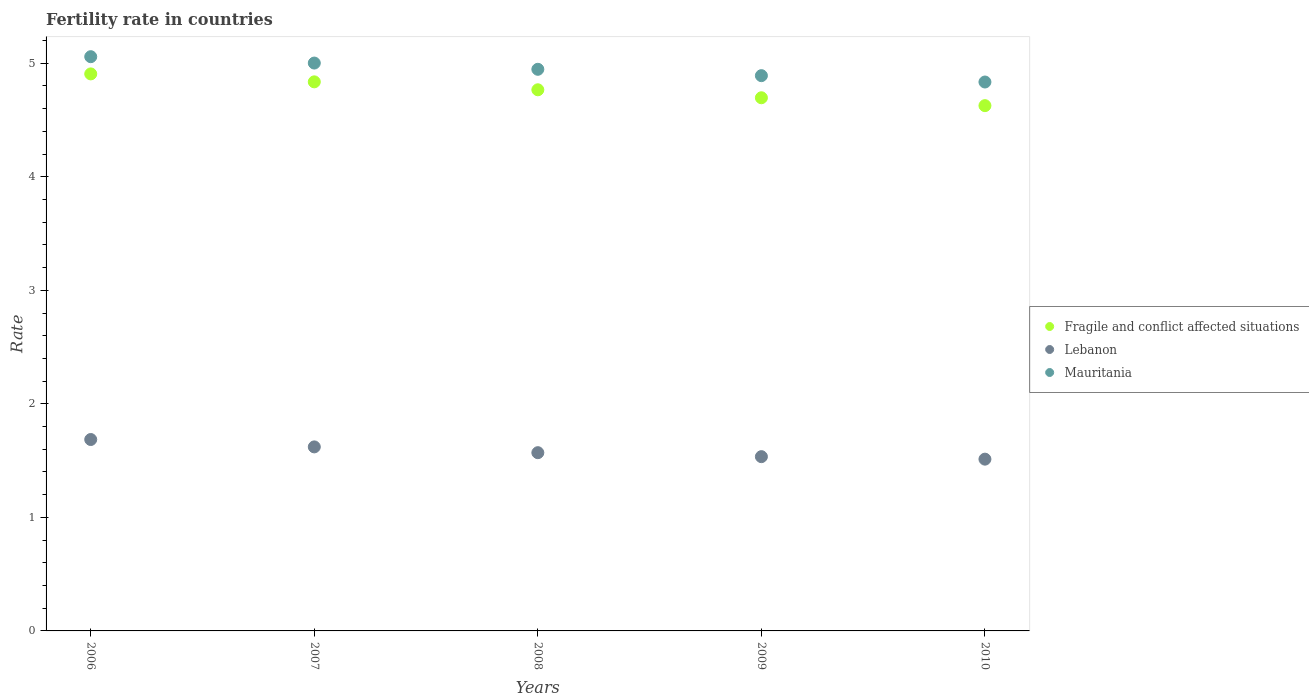How many different coloured dotlines are there?
Keep it short and to the point. 3. Is the number of dotlines equal to the number of legend labels?
Your response must be concise. Yes. What is the fertility rate in Lebanon in 2008?
Offer a terse response. 1.57. Across all years, what is the maximum fertility rate in Mauritania?
Provide a succinct answer. 5.06. Across all years, what is the minimum fertility rate in Fragile and conflict affected situations?
Your answer should be compact. 4.63. In which year was the fertility rate in Fragile and conflict affected situations maximum?
Ensure brevity in your answer.  2006. What is the total fertility rate in Fragile and conflict affected situations in the graph?
Provide a short and direct response. 23.83. What is the difference between the fertility rate in Fragile and conflict affected situations in 2007 and that in 2008?
Your answer should be compact. 0.07. What is the difference between the fertility rate in Fragile and conflict affected situations in 2009 and the fertility rate in Mauritania in 2010?
Offer a terse response. -0.14. What is the average fertility rate in Fragile and conflict affected situations per year?
Offer a terse response. 4.77. In the year 2010, what is the difference between the fertility rate in Fragile and conflict affected situations and fertility rate in Lebanon?
Keep it short and to the point. 3.11. What is the ratio of the fertility rate in Fragile and conflict affected situations in 2006 to that in 2010?
Provide a succinct answer. 1.06. What is the difference between the highest and the second highest fertility rate in Fragile and conflict affected situations?
Your answer should be very brief. 0.07. What is the difference between the highest and the lowest fertility rate in Lebanon?
Provide a succinct answer. 0.17. Is it the case that in every year, the sum of the fertility rate in Lebanon and fertility rate in Fragile and conflict affected situations  is greater than the fertility rate in Mauritania?
Your response must be concise. Yes. How many dotlines are there?
Offer a terse response. 3. How many years are there in the graph?
Offer a terse response. 5. What is the difference between two consecutive major ticks on the Y-axis?
Give a very brief answer. 1. Are the values on the major ticks of Y-axis written in scientific E-notation?
Provide a succinct answer. No. How many legend labels are there?
Ensure brevity in your answer.  3. What is the title of the graph?
Offer a terse response. Fertility rate in countries. Does "Sao Tome and Principe" appear as one of the legend labels in the graph?
Ensure brevity in your answer.  No. What is the label or title of the X-axis?
Offer a very short reply. Years. What is the label or title of the Y-axis?
Your answer should be very brief. Rate. What is the Rate of Fragile and conflict affected situations in 2006?
Keep it short and to the point. 4.91. What is the Rate in Lebanon in 2006?
Ensure brevity in your answer.  1.69. What is the Rate of Mauritania in 2006?
Your response must be concise. 5.06. What is the Rate of Fragile and conflict affected situations in 2007?
Make the answer very short. 4.84. What is the Rate in Lebanon in 2007?
Offer a terse response. 1.62. What is the Rate of Mauritania in 2007?
Offer a very short reply. 5. What is the Rate in Fragile and conflict affected situations in 2008?
Ensure brevity in your answer.  4.77. What is the Rate of Lebanon in 2008?
Provide a succinct answer. 1.57. What is the Rate in Mauritania in 2008?
Give a very brief answer. 4.95. What is the Rate of Fragile and conflict affected situations in 2009?
Keep it short and to the point. 4.7. What is the Rate in Lebanon in 2009?
Provide a short and direct response. 1.53. What is the Rate in Mauritania in 2009?
Give a very brief answer. 4.89. What is the Rate of Fragile and conflict affected situations in 2010?
Your answer should be compact. 4.63. What is the Rate of Lebanon in 2010?
Offer a terse response. 1.51. What is the Rate in Mauritania in 2010?
Provide a succinct answer. 4.83. Across all years, what is the maximum Rate of Fragile and conflict affected situations?
Ensure brevity in your answer.  4.91. Across all years, what is the maximum Rate of Lebanon?
Your response must be concise. 1.69. Across all years, what is the maximum Rate of Mauritania?
Provide a short and direct response. 5.06. Across all years, what is the minimum Rate of Fragile and conflict affected situations?
Offer a terse response. 4.63. Across all years, what is the minimum Rate in Lebanon?
Give a very brief answer. 1.51. Across all years, what is the minimum Rate in Mauritania?
Keep it short and to the point. 4.83. What is the total Rate of Fragile and conflict affected situations in the graph?
Your response must be concise. 23.83. What is the total Rate in Lebanon in the graph?
Make the answer very short. 7.92. What is the total Rate of Mauritania in the graph?
Your response must be concise. 24.73. What is the difference between the Rate of Fragile and conflict affected situations in 2006 and that in 2007?
Your answer should be compact. 0.07. What is the difference between the Rate of Lebanon in 2006 and that in 2007?
Offer a terse response. 0.07. What is the difference between the Rate of Mauritania in 2006 and that in 2007?
Give a very brief answer. 0.06. What is the difference between the Rate in Fragile and conflict affected situations in 2006 and that in 2008?
Make the answer very short. 0.14. What is the difference between the Rate in Lebanon in 2006 and that in 2008?
Keep it short and to the point. 0.12. What is the difference between the Rate in Mauritania in 2006 and that in 2008?
Your response must be concise. 0.11. What is the difference between the Rate in Fragile and conflict affected situations in 2006 and that in 2009?
Offer a terse response. 0.21. What is the difference between the Rate in Lebanon in 2006 and that in 2009?
Your response must be concise. 0.15. What is the difference between the Rate in Mauritania in 2006 and that in 2009?
Provide a short and direct response. 0.17. What is the difference between the Rate of Fragile and conflict affected situations in 2006 and that in 2010?
Your response must be concise. 0.28. What is the difference between the Rate in Lebanon in 2006 and that in 2010?
Provide a succinct answer. 0.17. What is the difference between the Rate of Mauritania in 2006 and that in 2010?
Offer a very short reply. 0.22. What is the difference between the Rate of Fragile and conflict affected situations in 2007 and that in 2008?
Ensure brevity in your answer.  0.07. What is the difference between the Rate in Lebanon in 2007 and that in 2008?
Keep it short and to the point. 0.05. What is the difference between the Rate in Mauritania in 2007 and that in 2008?
Offer a very short reply. 0.06. What is the difference between the Rate in Fragile and conflict affected situations in 2007 and that in 2009?
Your answer should be very brief. 0.14. What is the difference between the Rate in Lebanon in 2007 and that in 2009?
Your answer should be compact. 0.09. What is the difference between the Rate in Mauritania in 2007 and that in 2009?
Provide a succinct answer. 0.11. What is the difference between the Rate in Fragile and conflict affected situations in 2007 and that in 2010?
Provide a succinct answer. 0.21. What is the difference between the Rate of Lebanon in 2007 and that in 2010?
Make the answer very short. 0.11. What is the difference between the Rate in Mauritania in 2007 and that in 2010?
Your answer should be very brief. 0.17. What is the difference between the Rate in Fragile and conflict affected situations in 2008 and that in 2009?
Give a very brief answer. 0.07. What is the difference between the Rate in Lebanon in 2008 and that in 2009?
Offer a terse response. 0.04. What is the difference between the Rate in Mauritania in 2008 and that in 2009?
Your answer should be compact. 0.06. What is the difference between the Rate of Fragile and conflict affected situations in 2008 and that in 2010?
Provide a short and direct response. 0.14. What is the difference between the Rate in Lebanon in 2008 and that in 2010?
Offer a very short reply. 0.06. What is the difference between the Rate in Mauritania in 2008 and that in 2010?
Provide a succinct answer. 0.11. What is the difference between the Rate of Fragile and conflict affected situations in 2009 and that in 2010?
Ensure brevity in your answer.  0.07. What is the difference between the Rate in Lebanon in 2009 and that in 2010?
Your response must be concise. 0.02. What is the difference between the Rate in Mauritania in 2009 and that in 2010?
Keep it short and to the point. 0.06. What is the difference between the Rate in Fragile and conflict affected situations in 2006 and the Rate in Lebanon in 2007?
Give a very brief answer. 3.29. What is the difference between the Rate in Fragile and conflict affected situations in 2006 and the Rate in Mauritania in 2007?
Give a very brief answer. -0.1. What is the difference between the Rate in Lebanon in 2006 and the Rate in Mauritania in 2007?
Make the answer very short. -3.32. What is the difference between the Rate of Fragile and conflict affected situations in 2006 and the Rate of Lebanon in 2008?
Make the answer very short. 3.34. What is the difference between the Rate in Fragile and conflict affected situations in 2006 and the Rate in Mauritania in 2008?
Give a very brief answer. -0.04. What is the difference between the Rate in Lebanon in 2006 and the Rate in Mauritania in 2008?
Offer a very short reply. -3.26. What is the difference between the Rate of Fragile and conflict affected situations in 2006 and the Rate of Lebanon in 2009?
Offer a terse response. 3.37. What is the difference between the Rate of Fragile and conflict affected situations in 2006 and the Rate of Mauritania in 2009?
Your answer should be very brief. 0.02. What is the difference between the Rate of Lebanon in 2006 and the Rate of Mauritania in 2009?
Make the answer very short. -3.21. What is the difference between the Rate of Fragile and conflict affected situations in 2006 and the Rate of Lebanon in 2010?
Provide a short and direct response. 3.39. What is the difference between the Rate of Fragile and conflict affected situations in 2006 and the Rate of Mauritania in 2010?
Offer a terse response. 0.07. What is the difference between the Rate in Lebanon in 2006 and the Rate in Mauritania in 2010?
Your answer should be very brief. -3.15. What is the difference between the Rate in Fragile and conflict affected situations in 2007 and the Rate in Lebanon in 2008?
Your answer should be very brief. 3.27. What is the difference between the Rate of Fragile and conflict affected situations in 2007 and the Rate of Mauritania in 2008?
Keep it short and to the point. -0.11. What is the difference between the Rate in Lebanon in 2007 and the Rate in Mauritania in 2008?
Offer a terse response. -3.33. What is the difference between the Rate of Fragile and conflict affected situations in 2007 and the Rate of Lebanon in 2009?
Your answer should be very brief. 3.3. What is the difference between the Rate in Fragile and conflict affected situations in 2007 and the Rate in Mauritania in 2009?
Provide a short and direct response. -0.05. What is the difference between the Rate in Lebanon in 2007 and the Rate in Mauritania in 2009?
Offer a terse response. -3.27. What is the difference between the Rate in Fragile and conflict affected situations in 2007 and the Rate in Lebanon in 2010?
Your response must be concise. 3.32. What is the difference between the Rate of Fragile and conflict affected situations in 2007 and the Rate of Mauritania in 2010?
Your answer should be compact. 0. What is the difference between the Rate in Lebanon in 2007 and the Rate in Mauritania in 2010?
Make the answer very short. -3.21. What is the difference between the Rate in Fragile and conflict affected situations in 2008 and the Rate in Lebanon in 2009?
Give a very brief answer. 3.23. What is the difference between the Rate in Fragile and conflict affected situations in 2008 and the Rate in Mauritania in 2009?
Offer a terse response. -0.12. What is the difference between the Rate of Lebanon in 2008 and the Rate of Mauritania in 2009?
Your response must be concise. -3.32. What is the difference between the Rate in Fragile and conflict affected situations in 2008 and the Rate in Lebanon in 2010?
Keep it short and to the point. 3.25. What is the difference between the Rate of Fragile and conflict affected situations in 2008 and the Rate of Mauritania in 2010?
Offer a terse response. -0.07. What is the difference between the Rate of Lebanon in 2008 and the Rate of Mauritania in 2010?
Make the answer very short. -3.27. What is the difference between the Rate of Fragile and conflict affected situations in 2009 and the Rate of Lebanon in 2010?
Provide a succinct answer. 3.18. What is the difference between the Rate in Fragile and conflict affected situations in 2009 and the Rate in Mauritania in 2010?
Your response must be concise. -0.14. What is the difference between the Rate of Lebanon in 2009 and the Rate of Mauritania in 2010?
Make the answer very short. -3.3. What is the average Rate of Fragile and conflict affected situations per year?
Give a very brief answer. 4.77. What is the average Rate in Lebanon per year?
Offer a very short reply. 1.58. What is the average Rate in Mauritania per year?
Provide a short and direct response. 4.95. In the year 2006, what is the difference between the Rate of Fragile and conflict affected situations and Rate of Lebanon?
Keep it short and to the point. 3.22. In the year 2006, what is the difference between the Rate of Fragile and conflict affected situations and Rate of Mauritania?
Provide a short and direct response. -0.15. In the year 2006, what is the difference between the Rate in Lebanon and Rate in Mauritania?
Make the answer very short. -3.37. In the year 2007, what is the difference between the Rate of Fragile and conflict affected situations and Rate of Lebanon?
Your answer should be compact. 3.22. In the year 2007, what is the difference between the Rate in Fragile and conflict affected situations and Rate in Mauritania?
Your answer should be compact. -0.17. In the year 2007, what is the difference between the Rate of Lebanon and Rate of Mauritania?
Offer a very short reply. -3.38. In the year 2008, what is the difference between the Rate in Fragile and conflict affected situations and Rate in Lebanon?
Provide a succinct answer. 3.2. In the year 2008, what is the difference between the Rate in Fragile and conflict affected situations and Rate in Mauritania?
Provide a short and direct response. -0.18. In the year 2008, what is the difference between the Rate of Lebanon and Rate of Mauritania?
Give a very brief answer. -3.38. In the year 2009, what is the difference between the Rate of Fragile and conflict affected situations and Rate of Lebanon?
Make the answer very short. 3.16. In the year 2009, what is the difference between the Rate in Fragile and conflict affected situations and Rate in Mauritania?
Keep it short and to the point. -0.19. In the year 2009, what is the difference between the Rate of Lebanon and Rate of Mauritania?
Ensure brevity in your answer.  -3.36. In the year 2010, what is the difference between the Rate in Fragile and conflict affected situations and Rate in Lebanon?
Offer a terse response. 3.11. In the year 2010, what is the difference between the Rate of Fragile and conflict affected situations and Rate of Mauritania?
Your answer should be very brief. -0.21. In the year 2010, what is the difference between the Rate of Lebanon and Rate of Mauritania?
Your response must be concise. -3.32. What is the ratio of the Rate of Fragile and conflict affected situations in 2006 to that in 2007?
Offer a terse response. 1.01. What is the ratio of the Rate of Lebanon in 2006 to that in 2007?
Offer a terse response. 1.04. What is the ratio of the Rate in Mauritania in 2006 to that in 2007?
Offer a very short reply. 1.01. What is the ratio of the Rate of Fragile and conflict affected situations in 2006 to that in 2008?
Ensure brevity in your answer.  1.03. What is the ratio of the Rate of Lebanon in 2006 to that in 2008?
Ensure brevity in your answer.  1.07. What is the ratio of the Rate of Mauritania in 2006 to that in 2008?
Your answer should be very brief. 1.02. What is the ratio of the Rate of Fragile and conflict affected situations in 2006 to that in 2009?
Offer a very short reply. 1.04. What is the ratio of the Rate in Lebanon in 2006 to that in 2009?
Offer a terse response. 1.1. What is the ratio of the Rate of Mauritania in 2006 to that in 2009?
Your response must be concise. 1.03. What is the ratio of the Rate of Fragile and conflict affected situations in 2006 to that in 2010?
Keep it short and to the point. 1.06. What is the ratio of the Rate in Lebanon in 2006 to that in 2010?
Offer a terse response. 1.11. What is the ratio of the Rate in Mauritania in 2006 to that in 2010?
Keep it short and to the point. 1.05. What is the ratio of the Rate of Fragile and conflict affected situations in 2007 to that in 2008?
Ensure brevity in your answer.  1.01. What is the ratio of the Rate in Lebanon in 2007 to that in 2008?
Provide a succinct answer. 1.03. What is the ratio of the Rate of Mauritania in 2007 to that in 2008?
Provide a short and direct response. 1.01. What is the ratio of the Rate of Fragile and conflict affected situations in 2007 to that in 2009?
Offer a terse response. 1.03. What is the ratio of the Rate in Lebanon in 2007 to that in 2009?
Provide a succinct answer. 1.06. What is the ratio of the Rate in Mauritania in 2007 to that in 2009?
Keep it short and to the point. 1.02. What is the ratio of the Rate in Fragile and conflict affected situations in 2007 to that in 2010?
Your response must be concise. 1.05. What is the ratio of the Rate in Lebanon in 2007 to that in 2010?
Keep it short and to the point. 1.07. What is the ratio of the Rate in Mauritania in 2007 to that in 2010?
Provide a succinct answer. 1.03. What is the ratio of the Rate in Lebanon in 2008 to that in 2009?
Offer a terse response. 1.02. What is the ratio of the Rate of Mauritania in 2008 to that in 2009?
Offer a terse response. 1.01. What is the ratio of the Rate of Fragile and conflict affected situations in 2008 to that in 2010?
Keep it short and to the point. 1.03. What is the ratio of the Rate in Lebanon in 2008 to that in 2010?
Provide a succinct answer. 1.04. What is the ratio of the Rate in Mauritania in 2008 to that in 2010?
Make the answer very short. 1.02. What is the ratio of the Rate of Lebanon in 2009 to that in 2010?
Provide a short and direct response. 1.01. What is the ratio of the Rate in Mauritania in 2009 to that in 2010?
Give a very brief answer. 1.01. What is the difference between the highest and the second highest Rate of Fragile and conflict affected situations?
Ensure brevity in your answer.  0.07. What is the difference between the highest and the second highest Rate in Lebanon?
Ensure brevity in your answer.  0.07. What is the difference between the highest and the second highest Rate of Mauritania?
Make the answer very short. 0.06. What is the difference between the highest and the lowest Rate of Fragile and conflict affected situations?
Offer a very short reply. 0.28. What is the difference between the highest and the lowest Rate in Lebanon?
Your response must be concise. 0.17. What is the difference between the highest and the lowest Rate in Mauritania?
Provide a succinct answer. 0.22. 